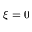<formula> <loc_0><loc_0><loc_500><loc_500>\xi = 0</formula> 